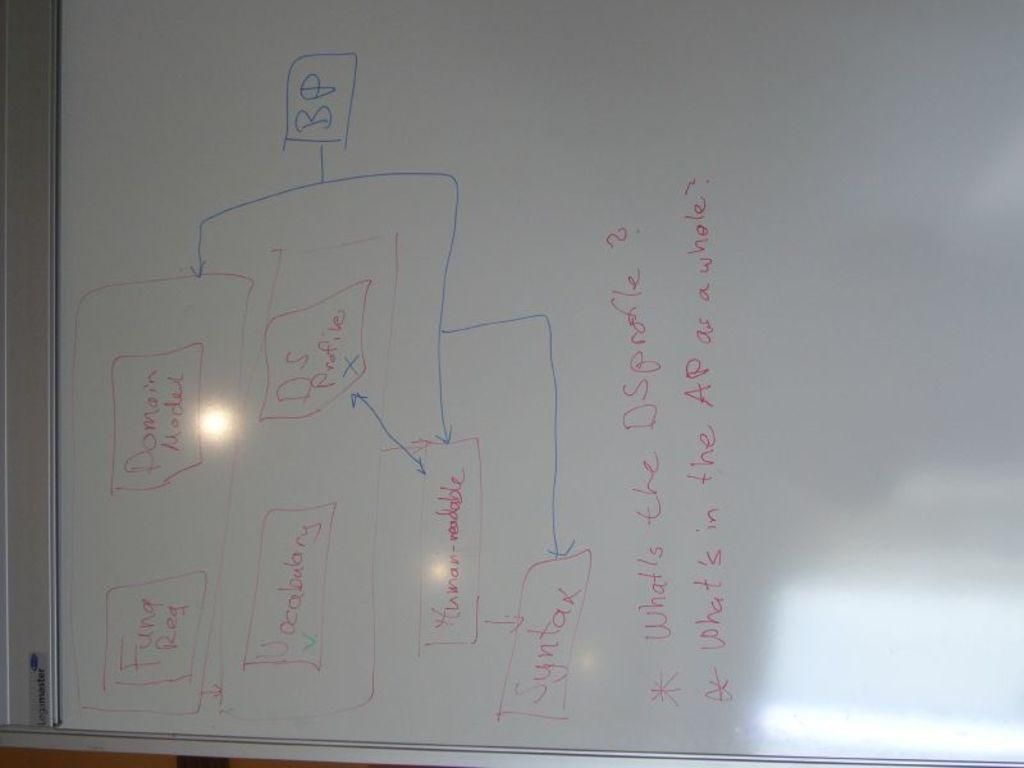Provide a one-sentence caption for the provided image. A whiteboard includes labels for syntax and vocabulary. 